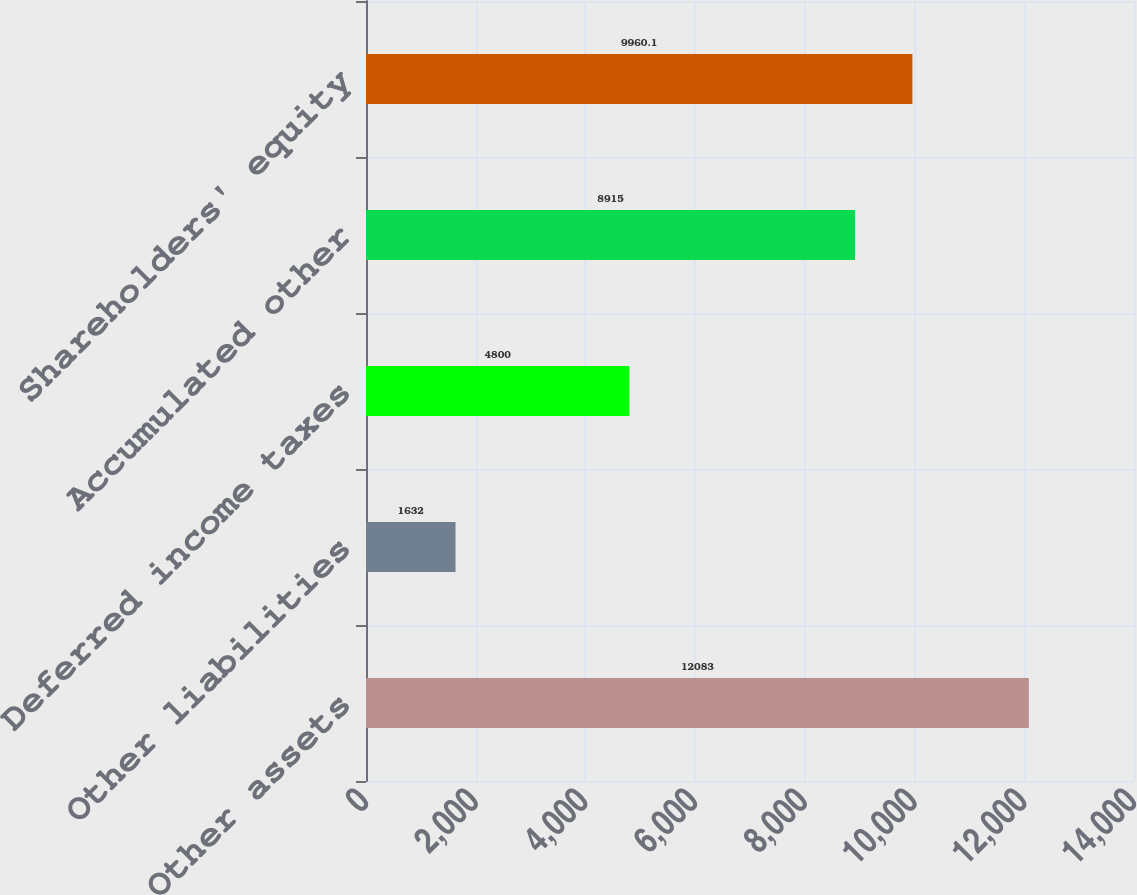<chart> <loc_0><loc_0><loc_500><loc_500><bar_chart><fcel>Other assets<fcel>Other liabilities<fcel>Deferred income taxes<fcel>Accumulated other<fcel>Shareholders' equity<nl><fcel>12083<fcel>1632<fcel>4800<fcel>8915<fcel>9960.1<nl></chart> 